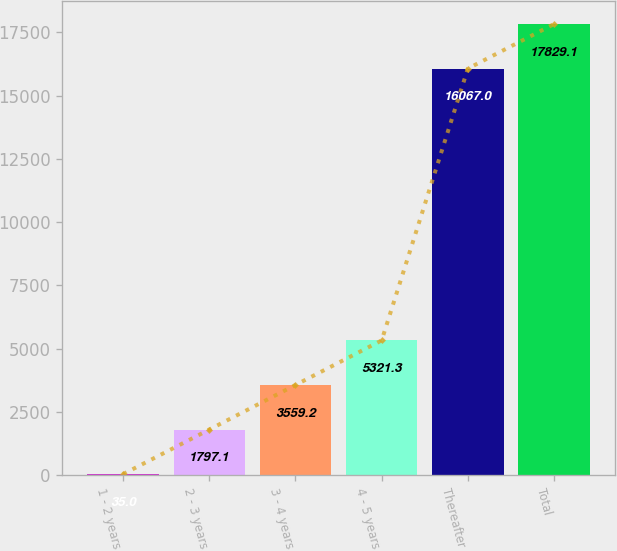Convert chart. <chart><loc_0><loc_0><loc_500><loc_500><bar_chart><fcel>1 - 2 years<fcel>2 - 3 years<fcel>3 - 4 years<fcel>4 - 5 years<fcel>Thereafter<fcel>Total<nl><fcel>35<fcel>1797.1<fcel>3559.2<fcel>5321.3<fcel>16067<fcel>17829.1<nl></chart> 